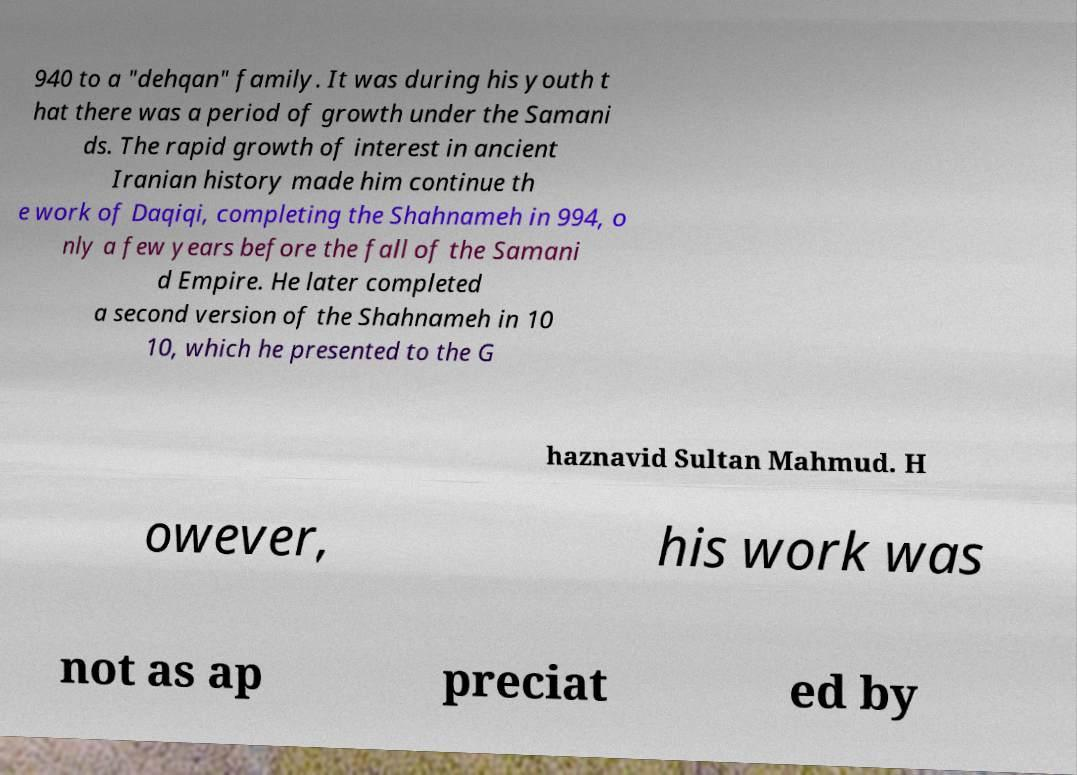Could you assist in decoding the text presented in this image and type it out clearly? 940 to a "dehqan" family. It was during his youth t hat there was a period of growth under the Samani ds. The rapid growth of interest in ancient Iranian history made him continue th e work of Daqiqi, completing the Shahnameh in 994, o nly a few years before the fall of the Samani d Empire. He later completed a second version of the Shahnameh in 10 10, which he presented to the G haznavid Sultan Mahmud. H owever, his work was not as ap preciat ed by 